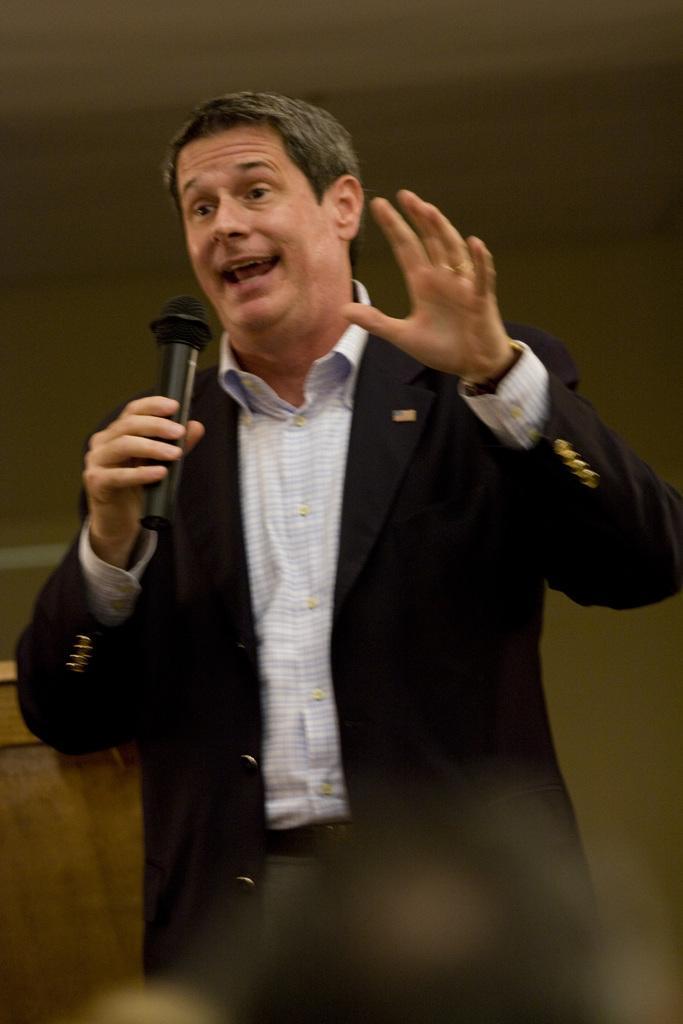How would you summarize this image in a sentence or two? In this image there is a man standing and speaking. He is holding a microphone in his hand. In the background there is wall. 